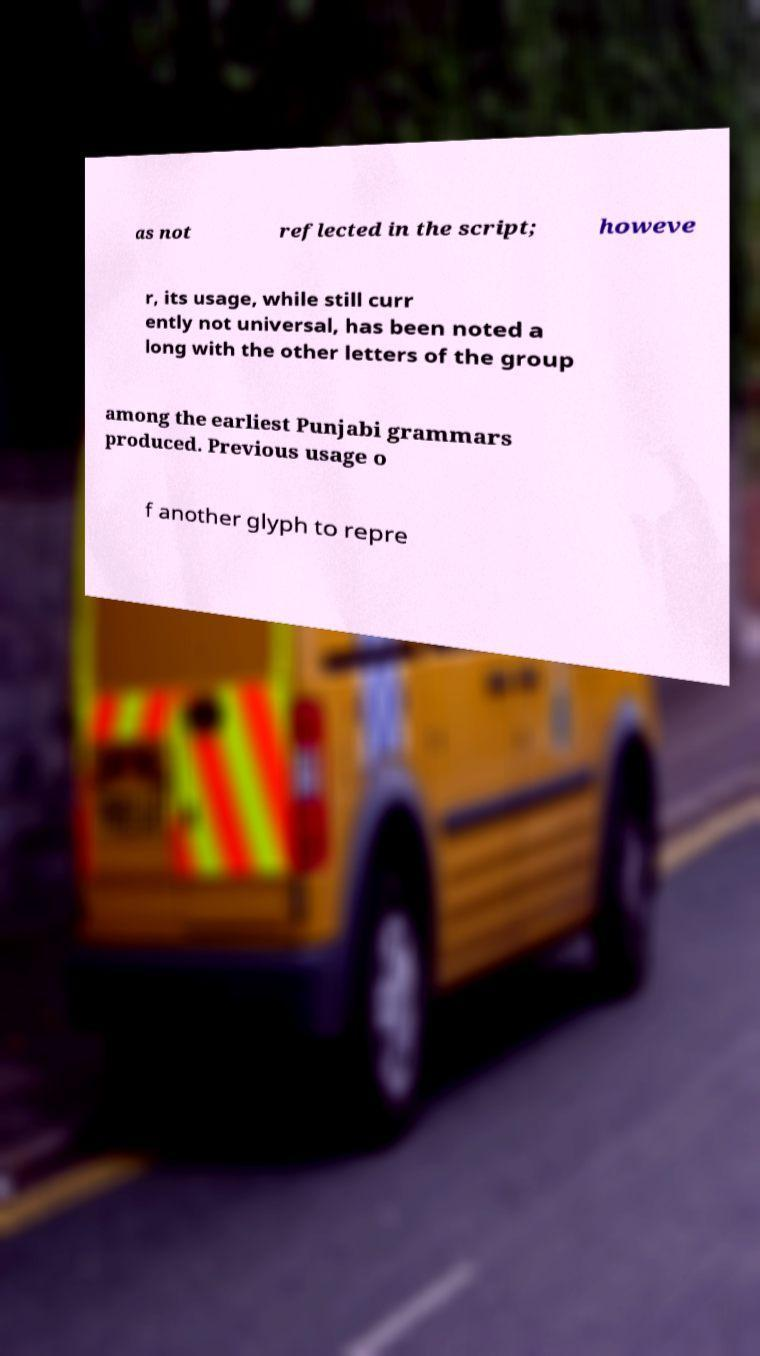Can you accurately transcribe the text from the provided image for me? as not reflected in the script; howeve r, its usage, while still curr ently not universal, has been noted a long with the other letters of the group among the earliest Punjabi grammars produced. Previous usage o f another glyph to repre 